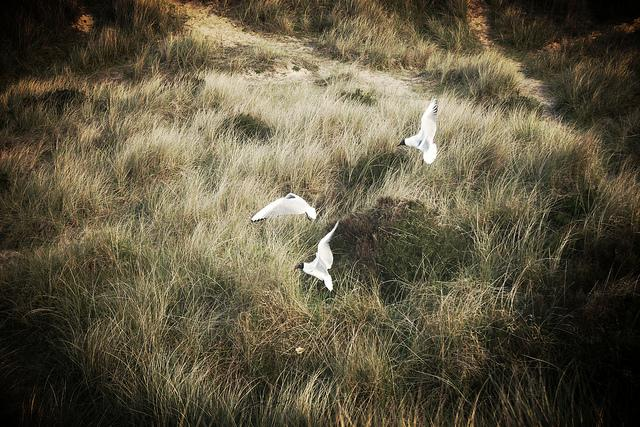What color are the beaks of these birds? black 